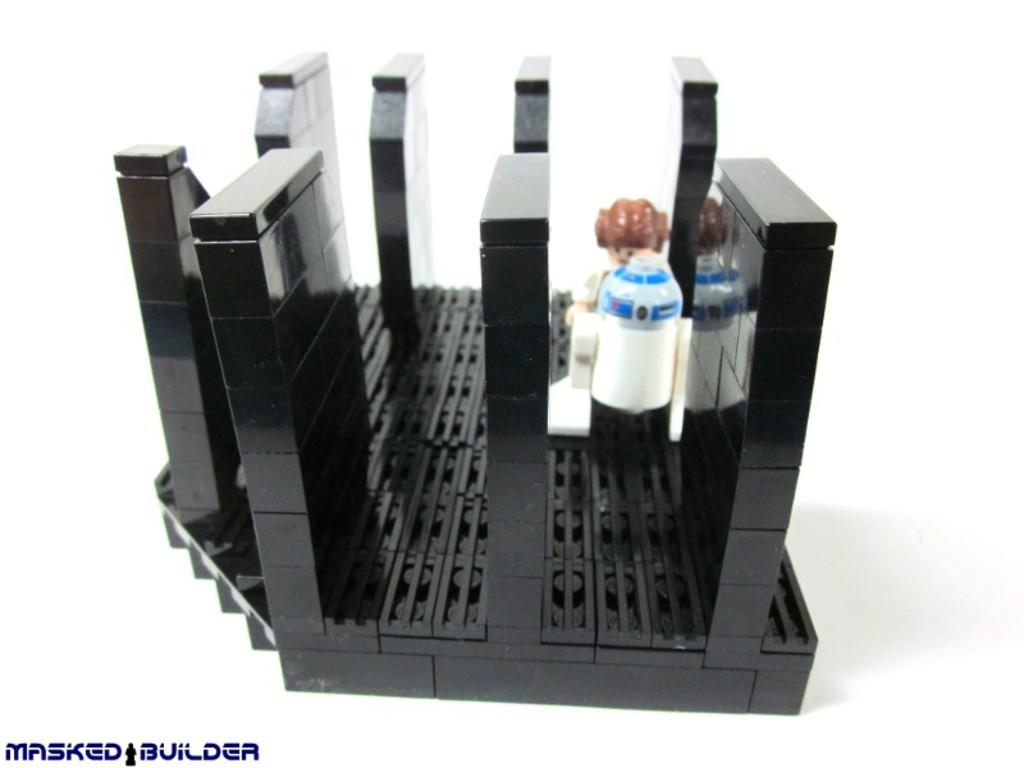<image>
Summarize the visual content of the image. A black structure with the words masked builder at the bottom left. 